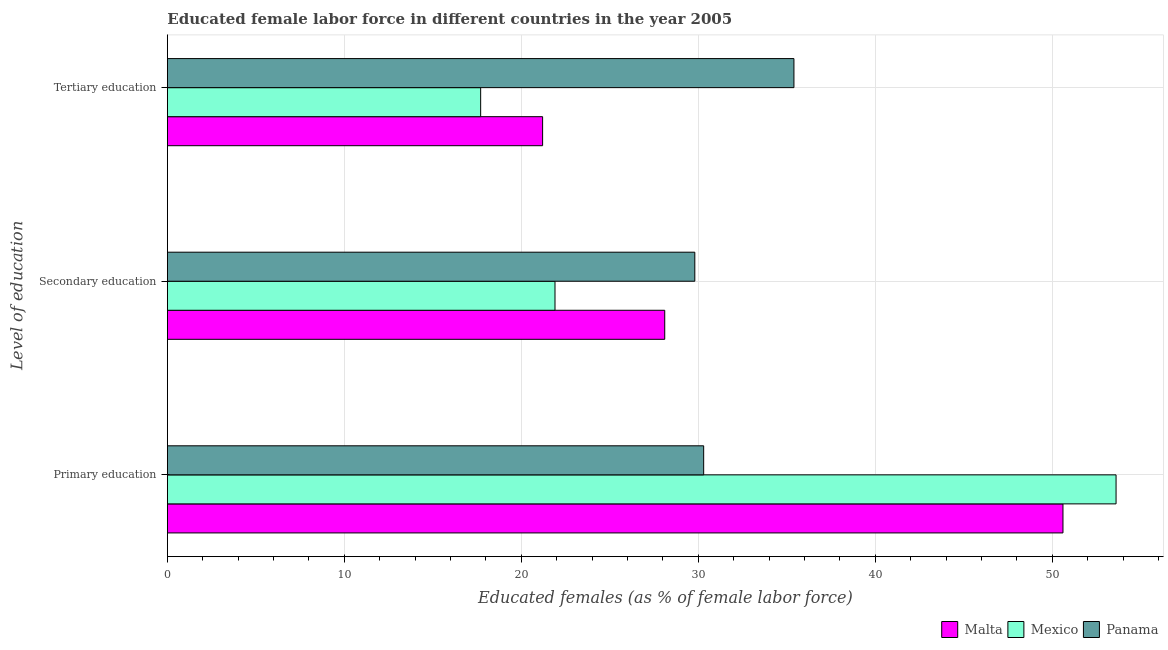How many different coloured bars are there?
Offer a terse response. 3. Are the number of bars on each tick of the Y-axis equal?
Provide a short and direct response. Yes. What is the label of the 2nd group of bars from the top?
Your answer should be compact. Secondary education. What is the percentage of female labor force who received primary education in Panama?
Offer a very short reply. 30.3. Across all countries, what is the maximum percentage of female labor force who received primary education?
Your response must be concise. 53.6. Across all countries, what is the minimum percentage of female labor force who received tertiary education?
Keep it short and to the point. 17.7. In which country was the percentage of female labor force who received tertiary education maximum?
Keep it short and to the point. Panama. In which country was the percentage of female labor force who received primary education minimum?
Provide a short and direct response. Panama. What is the total percentage of female labor force who received secondary education in the graph?
Provide a succinct answer. 79.8. What is the difference between the percentage of female labor force who received secondary education in Malta and that in Panama?
Offer a very short reply. -1.7. What is the difference between the percentage of female labor force who received secondary education in Malta and the percentage of female labor force who received tertiary education in Mexico?
Your answer should be compact. 10.4. What is the average percentage of female labor force who received secondary education per country?
Your response must be concise. 26.6. What is the difference between the percentage of female labor force who received primary education and percentage of female labor force who received secondary education in Malta?
Provide a succinct answer. 22.5. What is the ratio of the percentage of female labor force who received primary education in Malta to that in Mexico?
Your answer should be very brief. 0.94. Is the difference between the percentage of female labor force who received primary education in Panama and Mexico greater than the difference between the percentage of female labor force who received tertiary education in Panama and Mexico?
Offer a terse response. No. What is the difference between the highest and the second highest percentage of female labor force who received secondary education?
Provide a succinct answer. 1.7. What is the difference between the highest and the lowest percentage of female labor force who received tertiary education?
Keep it short and to the point. 17.7. In how many countries, is the percentage of female labor force who received secondary education greater than the average percentage of female labor force who received secondary education taken over all countries?
Offer a very short reply. 2. Is the sum of the percentage of female labor force who received primary education in Mexico and Panama greater than the maximum percentage of female labor force who received tertiary education across all countries?
Make the answer very short. Yes. What does the 1st bar from the top in Tertiary education represents?
Offer a terse response. Panama. What does the 2nd bar from the bottom in Secondary education represents?
Make the answer very short. Mexico. Is it the case that in every country, the sum of the percentage of female labor force who received primary education and percentage of female labor force who received secondary education is greater than the percentage of female labor force who received tertiary education?
Keep it short and to the point. Yes. How many bars are there?
Your answer should be very brief. 9. Are all the bars in the graph horizontal?
Give a very brief answer. Yes. Are the values on the major ticks of X-axis written in scientific E-notation?
Make the answer very short. No. Does the graph contain grids?
Offer a terse response. Yes. How many legend labels are there?
Make the answer very short. 3. What is the title of the graph?
Provide a short and direct response. Educated female labor force in different countries in the year 2005. What is the label or title of the X-axis?
Provide a succinct answer. Educated females (as % of female labor force). What is the label or title of the Y-axis?
Provide a succinct answer. Level of education. What is the Educated females (as % of female labor force) in Malta in Primary education?
Ensure brevity in your answer.  50.6. What is the Educated females (as % of female labor force) of Mexico in Primary education?
Make the answer very short. 53.6. What is the Educated females (as % of female labor force) in Panama in Primary education?
Your answer should be very brief. 30.3. What is the Educated females (as % of female labor force) in Malta in Secondary education?
Give a very brief answer. 28.1. What is the Educated females (as % of female labor force) of Mexico in Secondary education?
Offer a terse response. 21.9. What is the Educated females (as % of female labor force) of Panama in Secondary education?
Make the answer very short. 29.8. What is the Educated females (as % of female labor force) of Malta in Tertiary education?
Offer a terse response. 21.2. What is the Educated females (as % of female labor force) in Mexico in Tertiary education?
Provide a short and direct response. 17.7. What is the Educated females (as % of female labor force) in Panama in Tertiary education?
Provide a short and direct response. 35.4. Across all Level of education, what is the maximum Educated females (as % of female labor force) of Malta?
Your answer should be compact. 50.6. Across all Level of education, what is the maximum Educated females (as % of female labor force) in Mexico?
Provide a succinct answer. 53.6. Across all Level of education, what is the maximum Educated females (as % of female labor force) of Panama?
Ensure brevity in your answer.  35.4. Across all Level of education, what is the minimum Educated females (as % of female labor force) in Malta?
Ensure brevity in your answer.  21.2. Across all Level of education, what is the minimum Educated females (as % of female labor force) in Mexico?
Offer a terse response. 17.7. Across all Level of education, what is the minimum Educated females (as % of female labor force) in Panama?
Give a very brief answer. 29.8. What is the total Educated females (as % of female labor force) in Malta in the graph?
Offer a terse response. 99.9. What is the total Educated females (as % of female labor force) in Mexico in the graph?
Offer a terse response. 93.2. What is the total Educated females (as % of female labor force) in Panama in the graph?
Offer a very short reply. 95.5. What is the difference between the Educated females (as % of female labor force) in Mexico in Primary education and that in Secondary education?
Make the answer very short. 31.7. What is the difference between the Educated females (as % of female labor force) of Malta in Primary education and that in Tertiary education?
Keep it short and to the point. 29.4. What is the difference between the Educated females (as % of female labor force) in Mexico in Primary education and that in Tertiary education?
Your answer should be compact. 35.9. What is the difference between the Educated females (as % of female labor force) in Panama in Primary education and that in Tertiary education?
Your response must be concise. -5.1. What is the difference between the Educated females (as % of female labor force) in Malta in Secondary education and that in Tertiary education?
Provide a succinct answer. 6.9. What is the difference between the Educated females (as % of female labor force) of Panama in Secondary education and that in Tertiary education?
Give a very brief answer. -5.6. What is the difference between the Educated females (as % of female labor force) of Malta in Primary education and the Educated females (as % of female labor force) of Mexico in Secondary education?
Your answer should be compact. 28.7. What is the difference between the Educated females (as % of female labor force) of Malta in Primary education and the Educated females (as % of female labor force) of Panama in Secondary education?
Provide a short and direct response. 20.8. What is the difference between the Educated females (as % of female labor force) in Mexico in Primary education and the Educated females (as % of female labor force) in Panama in Secondary education?
Your answer should be compact. 23.8. What is the difference between the Educated females (as % of female labor force) of Malta in Primary education and the Educated females (as % of female labor force) of Mexico in Tertiary education?
Make the answer very short. 32.9. What is the difference between the Educated females (as % of female labor force) in Malta in Primary education and the Educated females (as % of female labor force) in Panama in Tertiary education?
Your response must be concise. 15.2. What is the difference between the Educated females (as % of female labor force) of Malta in Secondary education and the Educated females (as % of female labor force) of Panama in Tertiary education?
Make the answer very short. -7.3. What is the difference between the Educated females (as % of female labor force) of Mexico in Secondary education and the Educated females (as % of female labor force) of Panama in Tertiary education?
Offer a terse response. -13.5. What is the average Educated females (as % of female labor force) in Malta per Level of education?
Make the answer very short. 33.3. What is the average Educated females (as % of female labor force) of Mexico per Level of education?
Give a very brief answer. 31.07. What is the average Educated females (as % of female labor force) in Panama per Level of education?
Offer a very short reply. 31.83. What is the difference between the Educated females (as % of female labor force) of Malta and Educated females (as % of female labor force) of Panama in Primary education?
Your answer should be compact. 20.3. What is the difference between the Educated females (as % of female labor force) in Mexico and Educated females (as % of female labor force) in Panama in Primary education?
Your response must be concise. 23.3. What is the difference between the Educated females (as % of female labor force) in Malta and Educated females (as % of female labor force) in Panama in Secondary education?
Your answer should be compact. -1.7. What is the difference between the Educated females (as % of female labor force) of Mexico and Educated females (as % of female labor force) of Panama in Tertiary education?
Give a very brief answer. -17.7. What is the ratio of the Educated females (as % of female labor force) of Malta in Primary education to that in Secondary education?
Ensure brevity in your answer.  1.8. What is the ratio of the Educated females (as % of female labor force) of Mexico in Primary education to that in Secondary education?
Make the answer very short. 2.45. What is the ratio of the Educated females (as % of female labor force) of Panama in Primary education to that in Secondary education?
Keep it short and to the point. 1.02. What is the ratio of the Educated females (as % of female labor force) in Malta in Primary education to that in Tertiary education?
Make the answer very short. 2.39. What is the ratio of the Educated females (as % of female labor force) in Mexico in Primary education to that in Tertiary education?
Give a very brief answer. 3.03. What is the ratio of the Educated females (as % of female labor force) of Panama in Primary education to that in Tertiary education?
Provide a succinct answer. 0.86. What is the ratio of the Educated females (as % of female labor force) in Malta in Secondary education to that in Tertiary education?
Your answer should be compact. 1.33. What is the ratio of the Educated females (as % of female labor force) in Mexico in Secondary education to that in Tertiary education?
Ensure brevity in your answer.  1.24. What is the ratio of the Educated females (as % of female labor force) in Panama in Secondary education to that in Tertiary education?
Provide a short and direct response. 0.84. What is the difference between the highest and the second highest Educated females (as % of female labor force) of Mexico?
Your answer should be very brief. 31.7. What is the difference between the highest and the lowest Educated females (as % of female labor force) of Malta?
Give a very brief answer. 29.4. What is the difference between the highest and the lowest Educated females (as % of female labor force) of Mexico?
Offer a very short reply. 35.9. What is the difference between the highest and the lowest Educated females (as % of female labor force) in Panama?
Provide a short and direct response. 5.6. 